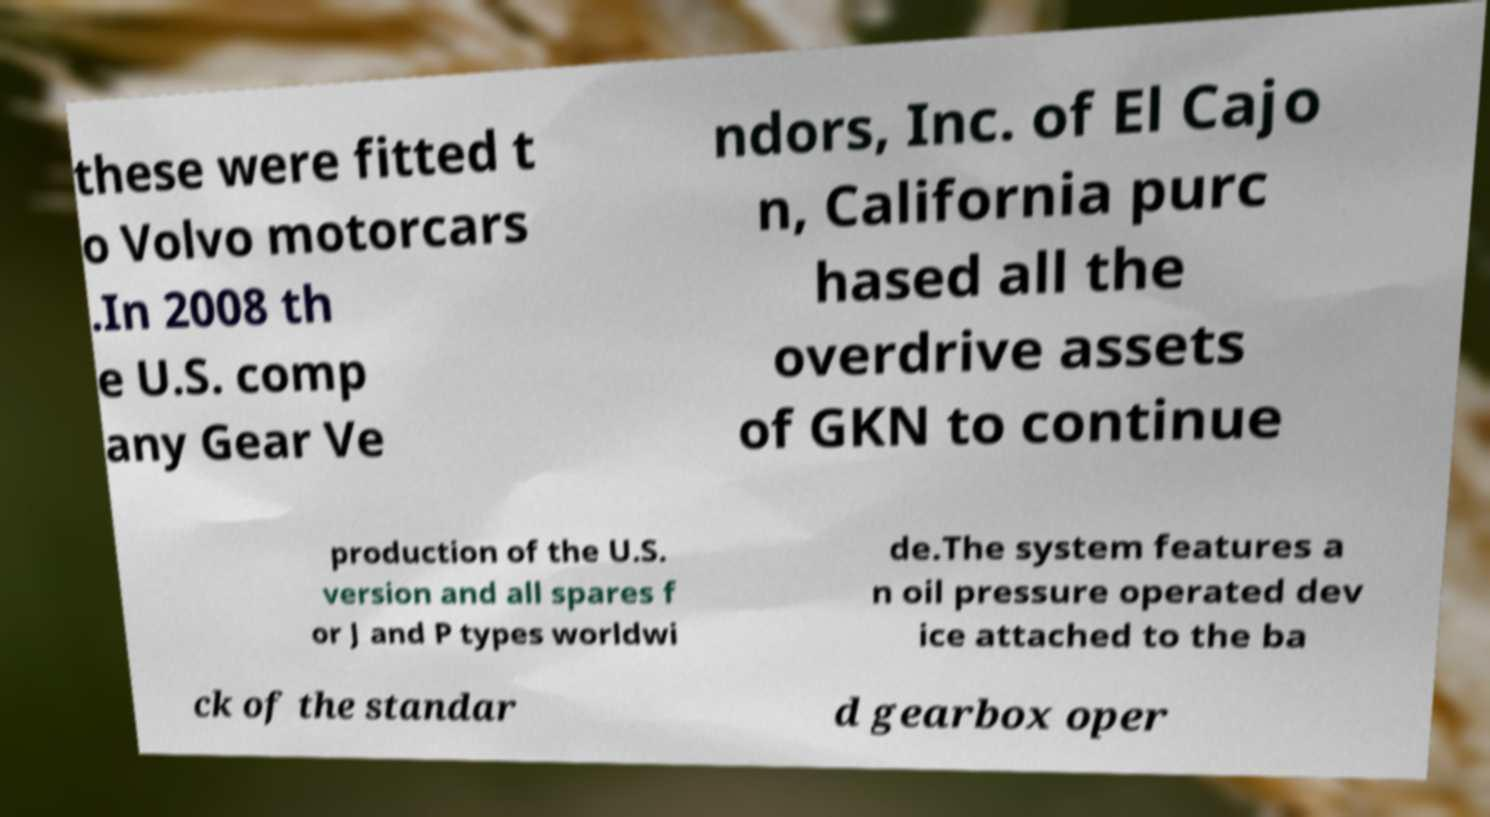Could you extract and type out the text from this image? these were fitted t o Volvo motorcars .In 2008 th e U.S. comp any Gear Ve ndors, Inc. of El Cajo n, California purc hased all the overdrive assets of GKN to continue production of the U.S. version and all spares f or J and P types worldwi de.The system features a n oil pressure operated dev ice attached to the ba ck of the standar d gearbox oper 